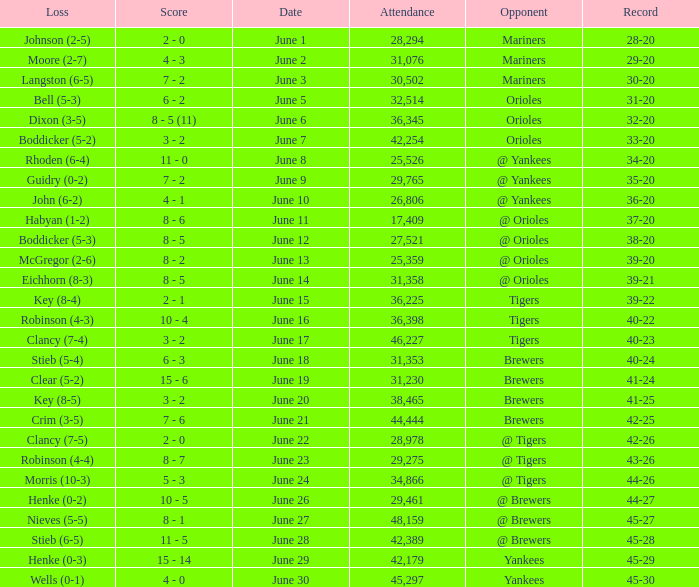What was the score when the Blue Jays had a record of 39-20? 8 - 2. 